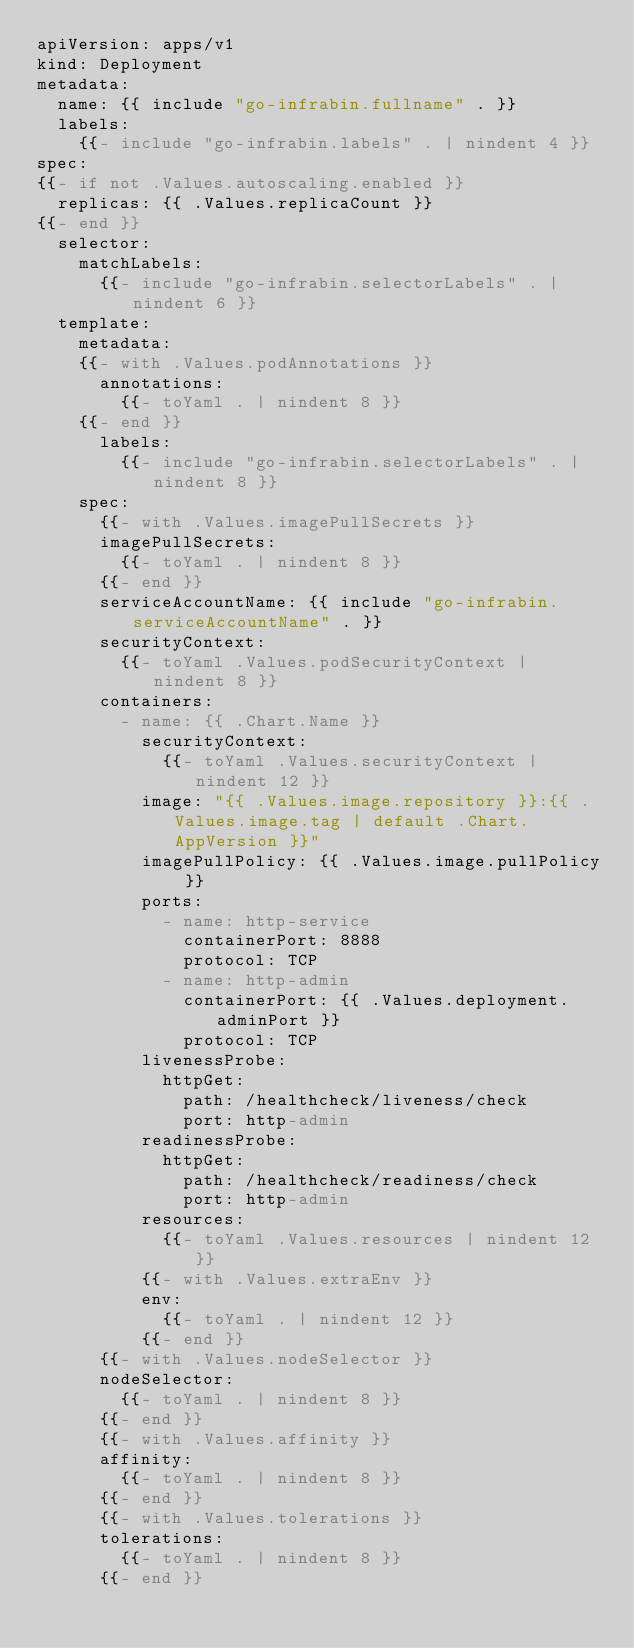<code> <loc_0><loc_0><loc_500><loc_500><_YAML_>apiVersion: apps/v1
kind: Deployment
metadata:
  name: {{ include "go-infrabin.fullname" . }}
  labels:
    {{- include "go-infrabin.labels" . | nindent 4 }}
spec:
{{- if not .Values.autoscaling.enabled }}
  replicas: {{ .Values.replicaCount }}
{{- end }}
  selector:
    matchLabels:
      {{- include "go-infrabin.selectorLabels" . | nindent 6 }}
  template:
    metadata:
    {{- with .Values.podAnnotations }}
      annotations:
        {{- toYaml . | nindent 8 }}
    {{- end }}
      labels:
        {{- include "go-infrabin.selectorLabels" . | nindent 8 }}
    spec:
      {{- with .Values.imagePullSecrets }}
      imagePullSecrets:
        {{- toYaml . | nindent 8 }}
      {{- end }}
      serviceAccountName: {{ include "go-infrabin.serviceAccountName" . }}
      securityContext:
        {{- toYaml .Values.podSecurityContext | nindent 8 }}
      containers:
        - name: {{ .Chart.Name }}
          securityContext:
            {{- toYaml .Values.securityContext | nindent 12 }}
          image: "{{ .Values.image.repository }}:{{ .Values.image.tag | default .Chart.AppVersion }}"
          imagePullPolicy: {{ .Values.image.pullPolicy }}
          ports:
            - name: http-service
              containerPort: 8888
              protocol: TCP
            - name: http-admin
              containerPort: {{ .Values.deployment.adminPort }}
              protocol: TCP
          livenessProbe:
            httpGet:
              path: /healthcheck/liveness/check
              port: http-admin
          readinessProbe:
            httpGet:
              path: /healthcheck/readiness/check
              port: http-admin
          resources:
            {{- toYaml .Values.resources | nindent 12 }}
          {{- with .Values.extraEnv }}
          env:
            {{- toYaml . | nindent 12 }}
          {{- end }}
      {{- with .Values.nodeSelector }}
      nodeSelector:
        {{- toYaml . | nindent 8 }}
      {{- end }}
      {{- with .Values.affinity }}
      affinity:
        {{- toYaml . | nindent 8 }}
      {{- end }}
      {{- with .Values.tolerations }}
      tolerations:
        {{- toYaml . | nindent 8 }}
      {{- end }}
</code> 